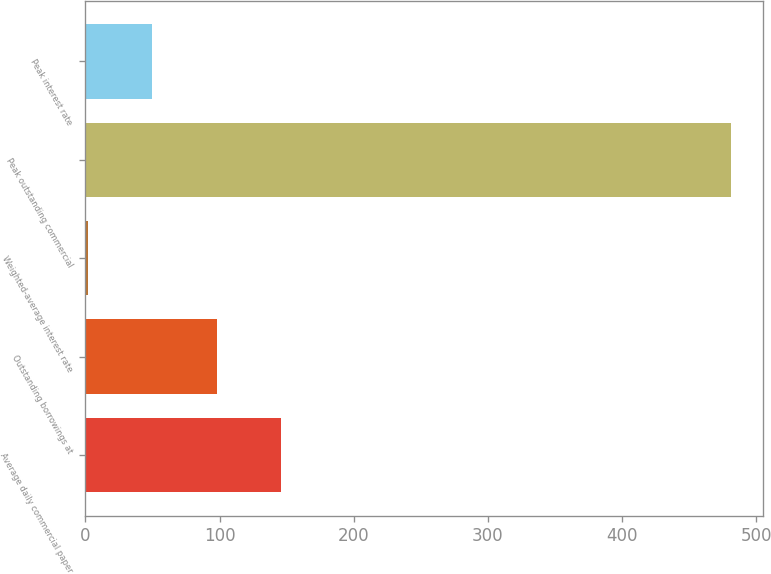Convert chart. <chart><loc_0><loc_0><loc_500><loc_500><bar_chart><fcel>Average daily commercial paper<fcel>Outstanding borrowings at<fcel>Weighted-average interest rate<fcel>Peak outstanding commercial<fcel>Peak interest rate<nl><fcel>145.67<fcel>97.76<fcel>1.94<fcel>481<fcel>49.85<nl></chart> 